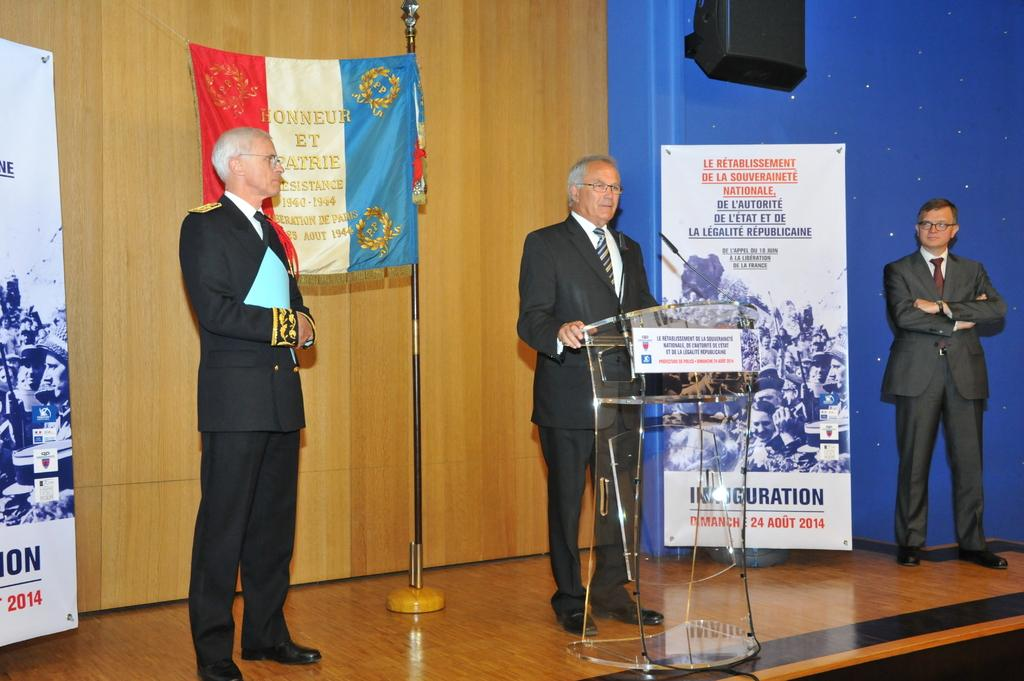How many people are in the image? There are three persons in the image. What is one of the persons doing in the image? One of the persons is standing in front of a mic. What can be seen in the background of the image? There are banners in the background of the image. What is written on the banners? The banners have writing on them. What type of nut is being used to stop the car in the image? There is no car or nut present in the image; it features three persons and banners with writing. Can you see the heart rate of the person standing in front of the mic in the image? There is no indication of heart rate or any medical equipment in the image. 